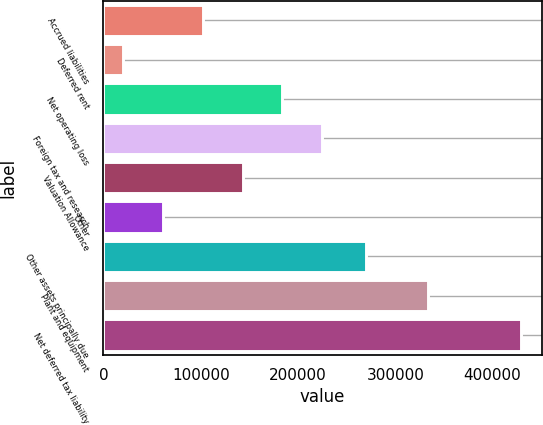Convert chart to OTSL. <chart><loc_0><loc_0><loc_500><loc_500><bar_chart><fcel>Accrued liabilities<fcel>Deferred rent<fcel>Net operating loss<fcel>Foreign tax and research<fcel>Valuation Allowance<fcel>Other<fcel>Other assets principally due<fcel>Plant and equipment<fcel>Net deferred tax liability<nl><fcel>102216<fcel>20484<fcel>183948<fcel>224814<fcel>143082<fcel>61349.9<fcel>269452<fcel>333248<fcel>429143<nl></chart> 